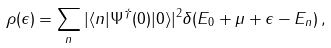<formula> <loc_0><loc_0><loc_500><loc_500>\rho ( \epsilon ) = \sum _ { n } | \langle n | \Psi ^ { \dagger } ( 0 ) | 0 \rangle | ^ { 2 } \delta ( E _ { 0 } + \mu + \epsilon - E _ { n } ) \, ,</formula> 